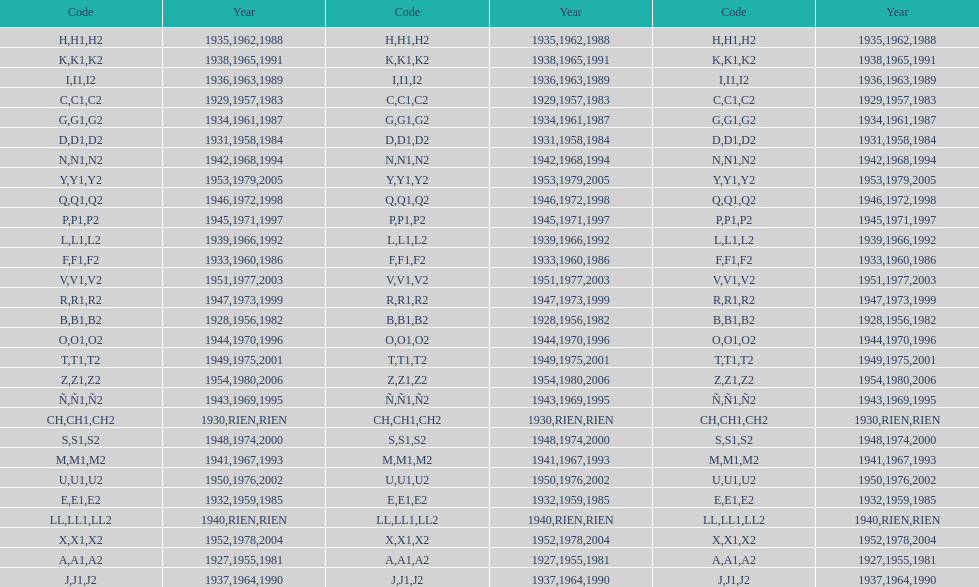Is the e code less than 1950? Yes. 